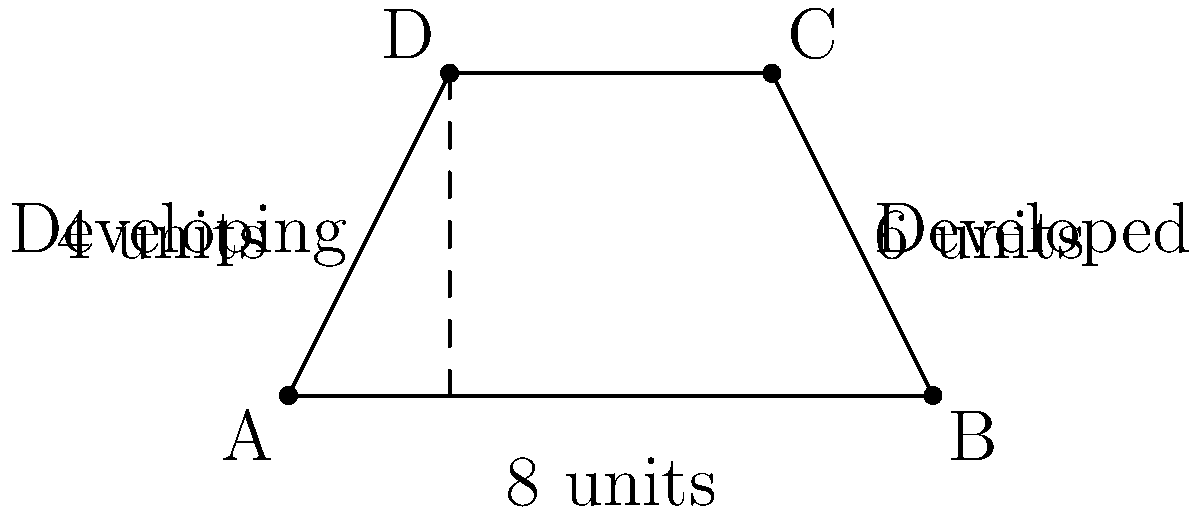In the context of international resource allocation, a trapezoid represents the distribution of resources between developed and developing nations. The parallel sides of the trapezoid are 8 units and 2 units long, representing the resource shares of developed and developing nations respectively. The height of the trapezoid is 4 units, symbolizing the gap in resource distribution. Calculate the total area of resource allocation represented by this trapezoid. How does this geometric representation reflect the unequal distribution of resources in the global economy? To calculate the area of the trapezoid representing resource allocation:

1. Recall the formula for the area of a trapezoid:
   $$A = \frac{1}{2}(b_1 + b_2)h$$
   where $A$ is the area, $b_1$ and $b_2$ are the parallel sides, and $h$ is the height.

2. Substitute the given values:
   $b_1 = 8$ (developed nations)
   $b_2 = 2$ (developing nations)
   $h = 4$ (gap in resource distribution)

3. Apply the formula:
   $$A = \frac{1}{2}(8 + 2) \times 4$$
   $$A = \frac{1}{2}(10) \times 4$$
   $$A = 5 \times 4 = 20$$

4. Interpret the result:
   The total area of 20 square units represents the overall resource allocation.
   The trapezoid shape visually demonstrates the inequality:
   - The wider top (8 units) shows more resources for developed nations.
   - The narrower bottom (2 units) indicates fewer resources for developing nations.
   - The slanted sides represent the disparity in resource distribution.

This geometric representation effectively illustrates the unequal distribution of resources in the global economy, with developed nations having access to a significantly larger share compared to developing nations.
Answer: 20 square units 